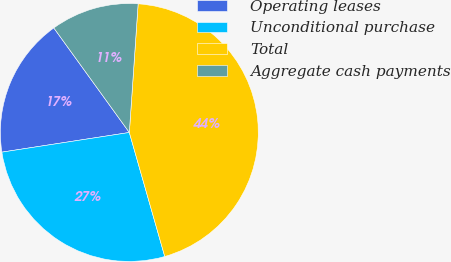Convert chart to OTSL. <chart><loc_0><loc_0><loc_500><loc_500><pie_chart><fcel>Operating leases<fcel>Unconditional purchase<fcel>Total<fcel>Aggregate cash payments<nl><fcel>17.48%<fcel>26.99%<fcel>44.48%<fcel>11.04%<nl></chart> 